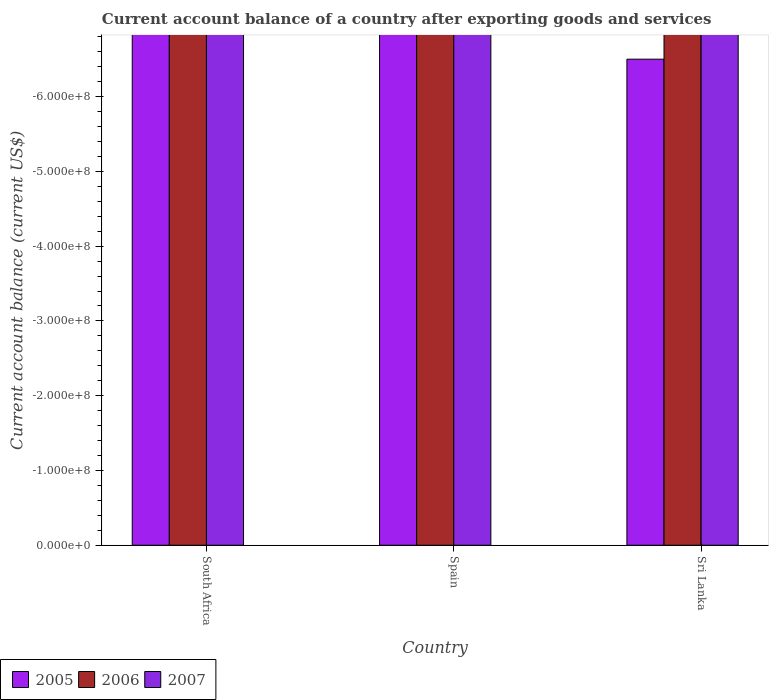Are the number of bars per tick equal to the number of legend labels?
Ensure brevity in your answer.  No. What is the label of the 3rd group of bars from the left?
Your response must be concise. Sri Lanka. Across all countries, what is the minimum account balance in 2005?
Give a very brief answer. 0. What is the average account balance in 2005 per country?
Your answer should be compact. 0. In how many countries, is the account balance in 2005 greater than the average account balance in 2005 taken over all countries?
Your answer should be very brief. 0. Are all the bars in the graph horizontal?
Your answer should be compact. No. How many countries are there in the graph?
Ensure brevity in your answer.  3. Where does the legend appear in the graph?
Provide a short and direct response. Bottom left. How many legend labels are there?
Your answer should be very brief. 3. What is the title of the graph?
Provide a succinct answer. Current account balance of a country after exporting goods and services. What is the label or title of the Y-axis?
Give a very brief answer. Current account balance (current US$). What is the Current account balance (current US$) in 2005 in South Africa?
Give a very brief answer. 0. What is the Current account balance (current US$) in 2006 in South Africa?
Ensure brevity in your answer.  0. What is the Current account balance (current US$) in 2007 in South Africa?
Provide a succinct answer. 0. What is the Current account balance (current US$) of 2005 in Spain?
Keep it short and to the point. 0. What is the Current account balance (current US$) in 2007 in Spain?
Make the answer very short. 0. What is the Current account balance (current US$) in 2006 in Sri Lanka?
Offer a terse response. 0. What is the Current account balance (current US$) of 2007 in Sri Lanka?
Your answer should be compact. 0. What is the total Current account balance (current US$) of 2006 in the graph?
Give a very brief answer. 0. What is the total Current account balance (current US$) in 2007 in the graph?
Make the answer very short. 0. What is the average Current account balance (current US$) of 2007 per country?
Provide a succinct answer. 0. 